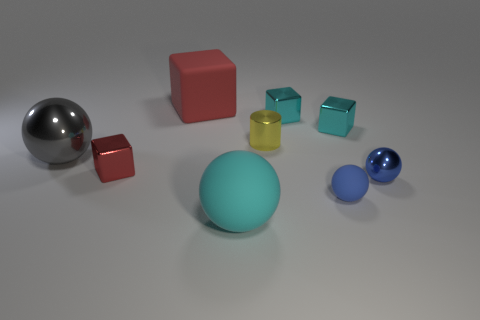There is another tiny thing that is the same shape as the blue rubber object; what material is it?
Offer a very short reply. Metal. How many blue things are small matte balls or tiny metal spheres?
Ensure brevity in your answer.  2. Is there any other thing of the same color as the metal cylinder?
Provide a short and direct response. No. There is a shiny thing that is in front of the tiny red metal thing that is left of the matte cube; what is its color?
Provide a succinct answer. Blue. Is the number of tiny red things that are behind the yellow object less than the number of large cyan matte objects that are behind the blue metal sphere?
Your answer should be very brief. No. What material is the thing that is the same color as the small matte sphere?
Provide a succinct answer. Metal. What number of objects are either big matte objects that are in front of the yellow cylinder or tiny blue balls?
Your response must be concise. 3. There is a thing that is to the left of the red metallic object; does it have the same size as the blue metal ball?
Provide a succinct answer. No. Are there fewer gray metallic things that are behind the tiny blue matte thing than tiny shiny cylinders?
Provide a succinct answer. No. There is a red thing that is the same size as the yellow thing; what material is it?
Your response must be concise. Metal. 